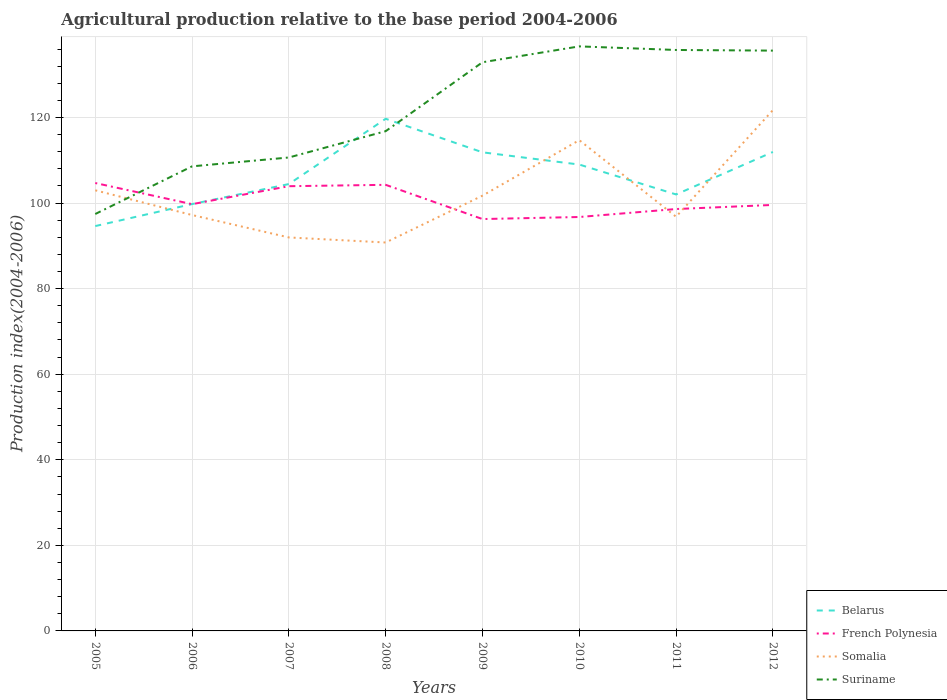Is the number of lines equal to the number of legend labels?
Make the answer very short. Yes. Across all years, what is the maximum agricultural production index in Somalia?
Your answer should be very brief. 90.79. In which year was the agricultural production index in Suriname maximum?
Keep it short and to the point. 2005. What is the total agricultural production index in Somalia in the graph?
Make the answer very short. 1.25. What is the difference between the highest and the second highest agricultural production index in Suriname?
Your answer should be very brief. 39.18. What is the difference between the highest and the lowest agricultural production index in Belarus?
Keep it short and to the point. 4. What is the difference between two consecutive major ticks on the Y-axis?
Give a very brief answer. 20. Does the graph contain grids?
Provide a short and direct response. Yes. Where does the legend appear in the graph?
Offer a very short reply. Bottom right. What is the title of the graph?
Offer a very short reply. Agricultural production relative to the base period 2004-2006. Does "Paraguay" appear as one of the legend labels in the graph?
Your answer should be compact. No. What is the label or title of the Y-axis?
Offer a very short reply. Production index(2004-2006). What is the Production index(2004-2006) in Belarus in 2005?
Your answer should be very brief. 94.63. What is the Production index(2004-2006) in French Polynesia in 2005?
Offer a very short reply. 104.69. What is the Production index(2004-2006) of Somalia in 2005?
Give a very brief answer. 102.99. What is the Production index(2004-2006) of Suriname in 2005?
Keep it short and to the point. 97.45. What is the Production index(2004-2006) of Belarus in 2006?
Offer a very short reply. 99.77. What is the Production index(2004-2006) of French Polynesia in 2006?
Offer a terse response. 99.75. What is the Production index(2004-2006) of Somalia in 2006?
Your answer should be very brief. 97.21. What is the Production index(2004-2006) in Suriname in 2006?
Provide a succinct answer. 108.59. What is the Production index(2004-2006) of Belarus in 2007?
Your answer should be compact. 104.45. What is the Production index(2004-2006) in French Polynesia in 2007?
Offer a very short reply. 103.95. What is the Production index(2004-2006) in Somalia in 2007?
Give a very brief answer. 91.97. What is the Production index(2004-2006) of Suriname in 2007?
Your answer should be compact. 110.66. What is the Production index(2004-2006) of Belarus in 2008?
Your answer should be compact. 119.71. What is the Production index(2004-2006) of French Polynesia in 2008?
Ensure brevity in your answer.  104.27. What is the Production index(2004-2006) of Somalia in 2008?
Provide a short and direct response. 90.79. What is the Production index(2004-2006) in Suriname in 2008?
Offer a terse response. 116.81. What is the Production index(2004-2006) of Belarus in 2009?
Make the answer very short. 111.87. What is the Production index(2004-2006) in French Polynesia in 2009?
Your response must be concise. 96.27. What is the Production index(2004-2006) in Somalia in 2009?
Your response must be concise. 101.74. What is the Production index(2004-2006) in Suriname in 2009?
Ensure brevity in your answer.  132.92. What is the Production index(2004-2006) in Belarus in 2010?
Your answer should be compact. 109.01. What is the Production index(2004-2006) in French Polynesia in 2010?
Your response must be concise. 96.75. What is the Production index(2004-2006) in Somalia in 2010?
Make the answer very short. 114.71. What is the Production index(2004-2006) of Suriname in 2010?
Give a very brief answer. 136.63. What is the Production index(2004-2006) in Belarus in 2011?
Provide a short and direct response. 102.02. What is the Production index(2004-2006) in French Polynesia in 2011?
Your response must be concise. 98.61. What is the Production index(2004-2006) of Somalia in 2011?
Give a very brief answer. 96.81. What is the Production index(2004-2006) of Suriname in 2011?
Offer a very short reply. 135.79. What is the Production index(2004-2006) in Belarus in 2012?
Provide a short and direct response. 111.95. What is the Production index(2004-2006) of French Polynesia in 2012?
Your answer should be compact. 99.57. What is the Production index(2004-2006) of Somalia in 2012?
Make the answer very short. 121.73. What is the Production index(2004-2006) in Suriname in 2012?
Give a very brief answer. 135.64. Across all years, what is the maximum Production index(2004-2006) in Belarus?
Give a very brief answer. 119.71. Across all years, what is the maximum Production index(2004-2006) in French Polynesia?
Give a very brief answer. 104.69. Across all years, what is the maximum Production index(2004-2006) in Somalia?
Ensure brevity in your answer.  121.73. Across all years, what is the maximum Production index(2004-2006) of Suriname?
Ensure brevity in your answer.  136.63. Across all years, what is the minimum Production index(2004-2006) of Belarus?
Offer a terse response. 94.63. Across all years, what is the minimum Production index(2004-2006) in French Polynesia?
Give a very brief answer. 96.27. Across all years, what is the minimum Production index(2004-2006) in Somalia?
Provide a succinct answer. 90.79. Across all years, what is the minimum Production index(2004-2006) of Suriname?
Offer a terse response. 97.45. What is the total Production index(2004-2006) in Belarus in the graph?
Offer a very short reply. 853.41. What is the total Production index(2004-2006) in French Polynesia in the graph?
Give a very brief answer. 803.86. What is the total Production index(2004-2006) in Somalia in the graph?
Give a very brief answer. 817.95. What is the total Production index(2004-2006) of Suriname in the graph?
Offer a very short reply. 974.49. What is the difference between the Production index(2004-2006) in Belarus in 2005 and that in 2006?
Ensure brevity in your answer.  -5.14. What is the difference between the Production index(2004-2006) of French Polynesia in 2005 and that in 2006?
Your answer should be very brief. 4.94. What is the difference between the Production index(2004-2006) of Somalia in 2005 and that in 2006?
Your answer should be very brief. 5.78. What is the difference between the Production index(2004-2006) in Suriname in 2005 and that in 2006?
Provide a short and direct response. -11.14. What is the difference between the Production index(2004-2006) in Belarus in 2005 and that in 2007?
Keep it short and to the point. -9.82. What is the difference between the Production index(2004-2006) in French Polynesia in 2005 and that in 2007?
Give a very brief answer. 0.74. What is the difference between the Production index(2004-2006) in Somalia in 2005 and that in 2007?
Your answer should be compact. 11.02. What is the difference between the Production index(2004-2006) in Suriname in 2005 and that in 2007?
Give a very brief answer. -13.21. What is the difference between the Production index(2004-2006) of Belarus in 2005 and that in 2008?
Provide a short and direct response. -25.08. What is the difference between the Production index(2004-2006) in French Polynesia in 2005 and that in 2008?
Make the answer very short. 0.42. What is the difference between the Production index(2004-2006) of Suriname in 2005 and that in 2008?
Your response must be concise. -19.36. What is the difference between the Production index(2004-2006) in Belarus in 2005 and that in 2009?
Provide a succinct answer. -17.24. What is the difference between the Production index(2004-2006) in French Polynesia in 2005 and that in 2009?
Offer a terse response. 8.42. What is the difference between the Production index(2004-2006) in Somalia in 2005 and that in 2009?
Offer a very short reply. 1.25. What is the difference between the Production index(2004-2006) of Suriname in 2005 and that in 2009?
Provide a succinct answer. -35.47. What is the difference between the Production index(2004-2006) of Belarus in 2005 and that in 2010?
Offer a terse response. -14.38. What is the difference between the Production index(2004-2006) in French Polynesia in 2005 and that in 2010?
Your response must be concise. 7.94. What is the difference between the Production index(2004-2006) in Somalia in 2005 and that in 2010?
Your answer should be compact. -11.72. What is the difference between the Production index(2004-2006) of Suriname in 2005 and that in 2010?
Give a very brief answer. -39.18. What is the difference between the Production index(2004-2006) of Belarus in 2005 and that in 2011?
Your answer should be very brief. -7.39. What is the difference between the Production index(2004-2006) in French Polynesia in 2005 and that in 2011?
Your answer should be very brief. 6.08. What is the difference between the Production index(2004-2006) in Somalia in 2005 and that in 2011?
Make the answer very short. 6.18. What is the difference between the Production index(2004-2006) in Suriname in 2005 and that in 2011?
Your answer should be compact. -38.34. What is the difference between the Production index(2004-2006) in Belarus in 2005 and that in 2012?
Provide a succinct answer. -17.32. What is the difference between the Production index(2004-2006) in French Polynesia in 2005 and that in 2012?
Provide a short and direct response. 5.12. What is the difference between the Production index(2004-2006) in Somalia in 2005 and that in 2012?
Provide a short and direct response. -18.74. What is the difference between the Production index(2004-2006) of Suriname in 2005 and that in 2012?
Provide a succinct answer. -38.19. What is the difference between the Production index(2004-2006) in Belarus in 2006 and that in 2007?
Make the answer very short. -4.68. What is the difference between the Production index(2004-2006) in Somalia in 2006 and that in 2007?
Offer a very short reply. 5.24. What is the difference between the Production index(2004-2006) in Suriname in 2006 and that in 2007?
Offer a very short reply. -2.07. What is the difference between the Production index(2004-2006) of Belarus in 2006 and that in 2008?
Ensure brevity in your answer.  -19.94. What is the difference between the Production index(2004-2006) of French Polynesia in 2006 and that in 2008?
Offer a terse response. -4.52. What is the difference between the Production index(2004-2006) in Somalia in 2006 and that in 2008?
Your answer should be very brief. 6.42. What is the difference between the Production index(2004-2006) in Suriname in 2006 and that in 2008?
Offer a very short reply. -8.22. What is the difference between the Production index(2004-2006) of French Polynesia in 2006 and that in 2009?
Your response must be concise. 3.48. What is the difference between the Production index(2004-2006) in Somalia in 2006 and that in 2009?
Give a very brief answer. -4.53. What is the difference between the Production index(2004-2006) of Suriname in 2006 and that in 2009?
Give a very brief answer. -24.33. What is the difference between the Production index(2004-2006) in Belarus in 2006 and that in 2010?
Offer a very short reply. -9.24. What is the difference between the Production index(2004-2006) of French Polynesia in 2006 and that in 2010?
Your response must be concise. 3. What is the difference between the Production index(2004-2006) of Somalia in 2006 and that in 2010?
Your answer should be compact. -17.5. What is the difference between the Production index(2004-2006) of Suriname in 2006 and that in 2010?
Offer a very short reply. -28.04. What is the difference between the Production index(2004-2006) of Belarus in 2006 and that in 2011?
Make the answer very short. -2.25. What is the difference between the Production index(2004-2006) in French Polynesia in 2006 and that in 2011?
Provide a succinct answer. 1.14. What is the difference between the Production index(2004-2006) in Somalia in 2006 and that in 2011?
Offer a very short reply. 0.4. What is the difference between the Production index(2004-2006) of Suriname in 2006 and that in 2011?
Your answer should be compact. -27.2. What is the difference between the Production index(2004-2006) in Belarus in 2006 and that in 2012?
Offer a very short reply. -12.18. What is the difference between the Production index(2004-2006) of French Polynesia in 2006 and that in 2012?
Your response must be concise. 0.18. What is the difference between the Production index(2004-2006) of Somalia in 2006 and that in 2012?
Offer a very short reply. -24.52. What is the difference between the Production index(2004-2006) in Suriname in 2006 and that in 2012?
Offer a terse response. -27.05. What is the difference between the Production index(2004-2006) in Belarus in 2007 and that in 2008?
Offer a terse response. -15.26. What is the difference between the Production index(2004-2006) of French Polynesia in 2007 and that in 2008?
Your answer should be very brief. -0.32. What is the difference between the Production index(2004-2006) of Somalia in 2007 and that in 2008?
Ensure brevity in your answer.  1.18. What is the difference between the Production index(2004-2006) of Suriname in 2007 and that in 2008?
Ensure brevity in your answer.  -6.15. What is the difference between the Production index(2004-2006) in Belarus in 2007 and that in 2009?
Offer a very short reply. -7.42. What is the difference between the Production index(2004-2006) of French Polynesia in 2007 and that in 2009?
Ensure brevity in your answer.  7.68. What is the difference between the Production index(2004-2006) of Somalia in 2007 and that in 2009?
Make the answer very short. -9.77. What is the difference between the Production index(2004-2006) of Suriname in 2007 and that in 2009?
Your answer should be compact. -22.26. What is the difference between the Production index(2004-2006) in Belarus in 2007 and that in 2010?
Your answer should be compact. -4.56. What is the difference between the Production index(2004-2006) in French Polynesia in 2007 and that in 2010?
Provide a short and direct response. 7.2. What is the difference between the Production index(2004-2006) in Somalia in 2007 and that in 2010?
Offer a terse response. -22.74. What is the difference between the Production index(2004-2006) of Suriname in 2007 and that in 2010?
Ensure brevity in your answer.  -25.97. What is the difference between the Production index(2004-2006) in Belarus in 2007 and that in 2011?
Provide a succinct answer. 2.43. What is the difference between the Production index(2004-2006) in French Polynesia in 2007 and that in 2011?
Provide a succinct answer. 5.34. What is the difference between the Production index(2004-2006) in Somalia in 2007 and that in 2011?
Offer a terse response. -4.84. What is the difference between the Production index(2004-2006) of Suriname in 2007 and that in 2011?
Make the answer very short. -25.13. What is the difference between the Production index(2004-2006) of Belarus in 2007 and that in 2012?
Keep it short and to the point. -7.5. What is the difference between the Production index(2004-2006) of French Polynesia in 2007 and that in 2012?
Ensure brevity in your answer.  4.38. What is the difference between the Production index(2004-2006) in Somalia in 2007 and that in 2012?
Ensure brevity in your answer.  -29.76. What is the difference between the Production index(2004-2006) of Suriname in 2007 and that in 2012?
Provide a short and direct response. -24.98. What is the difference between the Production index(2004-2006) of Belarus in 2008 and that in 2009?
Provide a succinct answer. 7.84. What is the difference between the Production index(2004-2006) in Somalia in 2008 and that in 2009?
Your answer should be compact. -10.95. What is the difference between the Production index(2004-2006) of Suriname in 2008 and that in 2009?
Make the answer very short. -16.11. What is the difference between the Production index(2004-2006) in French Polynesia in 2008 and that in 2010?
Keep it short and to the point. 7.52. What is the difference between the Production index(2004-2006) in Somalia in 2008 and that in 2010?
Your answer should be very brief. -23.92. What is the difference between the Production index(2004-2006) of Suriname in 2008 and that in 2010?
Make the answer very short. -19.82. What is the difference between the Production index(2004-2006) of Belarus in 2008 and that in 2011?
Ensure brevity in your answer.  17.69. What is the difference between the Production index(2004-2006) in French Polynesia in 2008 and that in 2011?
Offer a very short reply. 5.66. What is the difference between the Production index(2004-2006) of Somalia in 2008 and that in 2011?
Keep it short and to the point. -6.02. What is the difference between the Production index(2004-2006) of Suriname in 2008 and that in 2011?
Your answer should be compact. -18.98. What is the difference between the Production index(2004-2006) of Belarus in 2008 and that in 2012?
Make the answer very short. 7.76. What is the difference between the Production index(2004-2006) in Somalia in 2008 and that in 2012?
Give a very brief answer. -30.94. What is the difference between the Production index(2004-2006) in Suriname in 2008 and that in 2012?
Give a very brief answer. -18.83. What is the difference between the Production index(2004-2006) of Belarus in 2009 and that in 2010?
Provide a short and direct response. 2.86. What is the difference between the Production index(2004-2006) of French Polynesia in 2009 and that in 2010?
Keep it short and to the point. -0.48. What is the difference between the Production index(2004-2006) of Somalia in 2009 and that in 2010?
Offer a very short reply. -12.97. What is the difference between the Production index(2004-2006) of Suriname in 2009 and that in 2010?
Offer a terse response. -3.71. What is the difference between the Production index(2004-2006) of Belarus in 2009 and that in 2011?
Offer a very short reply. 9.85. What is the difference between the Production index(2004-2006) of French Polynesia in 2009 and that in 2011?
Provide a succinct answer. -2.34. What is the difference between the Production index(2004-2006) in Somalia in 2009 and that in 2011?
Your response must be concise. 4.93. What is the difference between the Production index(2004-2006) in Suriname in 2009 and that in 2011?
Provide a short and direct response. -2.87. What is the difference between the Production index(2004-2006) in Belarus in 2009 and that in 2012?
Provide a short and direct response. -0.08. What is the difference between the Production index(2004-2006) in French Polynesia in 2009 and that in 2012?
Keep it short and to the point. -3.3. What is the difference between the Production index(2004-2006) in Somalia in 2009 and that in 2012?
Give a very brief answer. -19.99. What is the difference between the Production index(2004-2006) in Suriname in 2009 and that in 2012?
Keep it short and to the point. -2.72. What is the difference between the Production index(2004-2006) in Belarus in 2010 and that in 2011?
Provide a short and direct response. 6.99. What is the difference between the Production index(2004-2006) of French Polynesia in 2010 and that in 2011?
Your answer should be compact. -1.86. What is the difference between the Production index(2004-2006) of Somalia in 2010 and that in 2011?
Provide a short and direct response. 17.9. What is the difference between the Production index(2004-2006) in Suriname in 2010 and that in 2011?
Provide a short and direct response. 0.84. What is the difference between the Production index(2004-2006) of Belarus in 2010 and that in 2012?
Keep it short and to the point. -2.94. What is the difference between the Production index(2004-2006) in French Polynesia in 2010 and that in 2012?
Give a very brief answer. -2.82. What is the difference between the Production index(2004-2006) of Somalia in 2010 and that in 2012?
Your response must be concise. -7.02. What is the difference between the Production index(2004-2006) in Suriname in 2010 and that in 2012?
Provide a short and direct response. 0.99. What is the difference between the Production index(2004-2006) of Belarus in 2011 and that in 2012?
Ensure brevity in your answer.  -9.93. What is the difference between the Production index(2004-2006) in French Polynesia in 2011 and that in 2012?
Give a very brief answer. -0.96. What is the difference between the Production index(2004-2006) of Somalia in 2011 and that in 2012?
Your response must be concise. -24.92. What is the difference between the Production index(2004-2006) in Belarus in 2005 and the Production index(2004-2006) in French Polynesia in 2006?
Provide a short and direct response. -5.12. What is the difference between the Production index(2004-2006) of Belarus in 2005 and the Production index(2004-2006) of Somalia in 2006?
Your response must be concise. -2.58. What is the difference between the Production index(2004-2006) in Belarus in 2005 and the Production index(2004-2006) in Suriname in 2006?
Your response must be concise. -13.96. What is the difference between the Production index(2004-2006) of French Polynesia in 2005 and the Production index(2004-2006) of Somalia in 2006?
Offer a very short reply. 7.48. What is the difference between the Production index(2004-2006) of Somalia in 2005 and the Production index(2004-2006) of Suriname in 2006?
Ensure brevity in your answer.  -5.6. What is the difference between the Production index(2004-2006) of Belarus in 2005 and the Production index(2004-2006) of French Polynesia in 2007?
Make the answer very short. -9.32. What is the difference between the Production index(2004-2006) in Belarus in 2005 and the Production index(2004-2006) in Somalia in 2007?
Your answer should be compact. 2.66. What is the difference between the Production index(2004-2006) in Belarus in 2005 and the Production index(2004-2006) in Suriname in 2007?
Give a very brief answer. -16.03. What is the difference between the Production index(2004-2006) in French Polynesia in 2005 and the Production index(2004-2006) in Somalia in 2007?
Give a very brief answer. 12.72. What is the difference between the Production index(2004-2006) in French Polynesia in 2005 and the Production index(2004-2006) in Suriname in 2007?
Your answer should be compact. -5.97. What is the difference between the Production index(2004-2006) in Somalia in 2005 and the Production index(2004-2006) in Suriname in 2007?
Keep it short and to the point. -7.67. What is the difference between the Production index(2004-2006) in Belarus in 2005 and the Production index(2004-2006) in French Polynesia in 2008?
Offer a terse response. -9.64. What is the difference between the Production index(2004-2006) in Belarus in 2005 and the Production index(2004-2006) in Somalia in 2008?
Your response must be concise. 3.84. What is the difference between the Production index(2004-2006) of Belarus in 2005 and the Production index(2004-2006) of Suriname in 2008?
Your response must be concise. -22.18. What is the difference between the Production index(2004-2006) of French Polynesia in 2005 and the Production index(2004-2006) of Suriname in 2008?
Give a very brief answer. -12.12. What is the difference between the Production index(2004-2006) in Somalia in 2005 and the Production index(2004-2006) in Suriname in 2008?
Provide a succinct answer. -13.82. What is the difference between the Production index(2004-2006) in Belarus in 2005 and the Production index(2004-2006) in French Polynesia in 2009?
Ensure brevity in your answer.  -1.64. What is the difference between the Production index(2004-2006) of Belarus in 2005 and the Production index(2004-2006) of Somalia in 2009?
Provide a succinct answer. -7.11. What is the difference between the Production index(2004-2006) in Belarus in 2005 and the Production index(2004-2006) in Suriname in 2009?
Keep it short and to the point. -38.29. What is the difference between the Production index(2004-2006) in French Polynesia in 2005 and the Production index(2004-2006) in Somalia in 2009?
Ensure brevity in your answer.  2.95. What is the difference between the Production index(2004-2006) in French Polynesia in 2005 and the Production index(2004-2006) in Suriname in 2009?
Give a very brief answer. -28.23. What is the difference between the Production index(2004-2006) in Somalia in 2005 and the Production index(2004-2006) in Suriname in 2009?
Keep it short and to the point. -29.93. What is the difference between the Production index(2004-2006) of Belarus in 2005 and the Production index(2004-2006) of French Polynesia in 2010?
Ensure brevity in your answer.  -2.12. What is the difference between the Production index(2004-2006) in Belarus in 2005 and the Production index(2004-2006) in Somalia in 2010?
Offer a terse response. -20.08. What is the difference between the Production index(2004-2006) of Belarus in 2005 and the Production index(2004-2006) of Suriname in 2010?
Ensure brevity in your answer.  -42. What is the difference between the Production index(2004-2006) in French Polynesia in 2005 and the Production index(2004-2006) in Somalia in 2010?
Your answer should be very brief. -10.02. What is the difference between the Production index(2004-2006) of French Polynesia in 2005 and the Production index(2004-2006) of Suriname in 2010?
Keep it short and to the point. -31.94. What is the difference between the Production index(2004-2006) of Somalia in 2005 and the Production index(2004-2006) of Suriname in 2010?
Give a very brief answer. -33.64. What is the difference between the Production index(2004-2006) of Belarus in 2005 and the Production index(2004-2006) of French Polynesia in 2011?
Offer a very short reply. -3.98. What is the difference between the Production index(2004-2006) of Belarus in 2005 and the Production index(2004-2006) of Somalia in 2011?
Your response must be concise. -2.18. What is the difference between the Production index(2004-2006) in Belarus in 2005 and the Production index(2004-2006) in Suriname in 2011?
Offer a terse response. -41.16. What is the difference between the Production index(2004-2006) in French Polynesia in 2005 and the Production index(2004-2006) in Somalia in 2011?
Your answer should be very brief. 7.88. What is the difference between the Production index(2004-2006) of French Polynesia in 2005 and the Production index(2004-2006) of Suriname in 2011?
Make the answer very short. -31.1. What is the difference between the Production index(2004-2006) of Somalia in 2005 and the Production index(2004-2006) of Suriname in 2011?
Your answer should be very brief. -32.8. What is the difference between the Production index(2004-2006) of Belarus in 2005 and the Production index(2004-2006) of French Polynesia in 2012?
Provide a succinct answer. -4.94. What is the difference between the Production index(2004-2006) of Belarus in 2005 and the Production index(2004-2006) of Somalia in 2012?
Keep it short and to the point. -27.1. What is the difference between the Production index(2004-2006) in Belarus in 2005 and the Production index(2004-2006) in Suriname in 2012?
Make the answer very short. -41.01. What is the difference between the Production index(2004-2006) in French Polynesia in 2005 and the Production index(2004-2006) in Somalia in 2012?
Provide a short and direct response. -17.04. What is the difference between the Production index(2004-2006) of French Polynesia in 2005 and the Production index(2004-2006) of Suriname in 2012?
Your answer should be very brief. -30.95. What is the difference between the Production index(2004-2006) in Somalia in 2005 and the Production index(2004-2006) in Suriname in 2012?
Offer a terse response. -32.65. What is the difference between the Production index(2004-2006) of Belarus in 2006 and the Production index(2004-2006) of French Polynesia in 2007?
Provide a short and direct response. -4.18. What is the difference between the Production index(2004-2006) of Belarus in 2006 and the Production index(2004-2006) of Suriname in 2007?
Provide a short and direct response. -10.89. What is the difference between the Production index(2004-2006) in French Polynesia in 2006 and the Production index(2004-2006) in Somalia in 2007?
Your answer should be compact. 7.78. What is the difference between the Production index(2004-2006) in French Polynesia in 2006 and the Production index(2004-2006) in Suriname in 2007?
Ensure brevity in your answer.  -10.91. What is the difference between the Production index(2004-2006) in Somalia in 2006 and the Production index(2004-2006) in Suriname in 2007?
Give a very brief answer. -13.45. What is the difference between the Production index(2004-2006) in Belarus in 2006 and the Production index(2004-2006) in Somalia in 2008?
Provide a succinct answer. 8.98. What is the difference between the Production index(2004-2006) of Belarus in 2006 and the Production index(2004-2006) of Suriname in 2008?
Ensure brevity in your answer.  -17.04. What is the difference between the Production index(2004-2006) in French Polynesia in 2006 and the Production index(2004-2006) in Somalia in 2008?
Make the answer very short. 8.96. What is the difference between the Production index(2004-2006) of French Polynesia in 2006 and the Production index(2004-2006) of Suriname in 2008?
Keep it short and to the point. -17.06. What is the difference between the Production index(2004-2006) in Somalia in 2006 and the Production index(2004-2006) in Suriname in 2008?
Make the answer very short. -19.6. What is the difference between the Production index(2004-2006) of Belarus in 2006 and the Production index(2004-2006) of Somalia in 2009?
Your answer should be compact. -1.97. What is the difference between the Production index(2004-2006) of Belarus in 2006 and the Production index(2004-2006) of Suriname in 2009?
Give a very brief answer. -33.15. What is the difference between the Production index(2004-2006) in French Polynesia in 2006 and the Production index(2004-2006) in Somalia in 2009?
Your answer should be very brief. -1.99. What is the difference between the Production index(2004-2006) of French Polynesia in 2006 and the Production index(2004-2006) of Suriname in 2009?
Provide a succinct answer. -33.17. What is the difference between the Production index(2004-2006) of Somalia in 2006 and the Production index(2004-2006) of Suriname in 2009?
Give a very brief answer. -35.71. What is the difference between the Production index(2004-2006) in Belarus in 2006 and the Production index(2004-2006) in French Polynesia in 2010?
Make the answer very short. 3.02. What is the difference between the Production index(2004-2006) in Belarus in 2006 and the Production index(2004-2006) in Somalia in 2010?
Your answer should be very brief. -14.94. What is the difference between the Production index(2004-2006) in Belarus in 2006 and the Production index(2004-2006) in Suriname in 2010?
Provide a short and direct response. -36.86. What is the difference between the Production index(2004-2006) of French Polynesia in 2006 and the Production index(2004-2006) of Somalia in 2010?
Make the answer very short. -14.96. What is the difference between the Production index(2004-2006) of French Polynesia in 2006 and the Production index(2004-2006) of Suriname in 2010?
Your response must be concise. -36.88. What is the difference between the Production index(2004-2006) in Somalia in 2006 and the Production index(2004-2006) in Suriname in 2010?
Your response must be concise. -39.42. What is the difference between the Production index(2004-2006) of Belarus in 2006 and the Production index(2004-2006) of French Polynesia in 2011?
Offer a very short reply. 1.16. What is the difference between the Production index(2004-2006) in Belarus in 2006 and the Production index(2004-2006) in Somalia in 2011?
Provide a succinct answer. 2.96. What is the difference between the Production index(2004-2006) of Belarus in 2006 and the Production index(2004-2006) of Suriname in 2011?
Your answer should be very brief. -36.02. What is the difference between the Production index(2004-2006) of French Polynesia in 2006 and the Production index(2004-2006) of Somalia in 2011?
Offer a very short reply. 2.94. What is the difference between the Production index(2004-2006) in French Polynesia in 2006 and the Production index(2004-2006) in Suriname in 2011?
Your response must be concise. -36.04. What is the difference between the Production index(2004-2006) in Somalia in 2006 and the Production index(2004-2006) in Suriname in 2011?
Your answer should be compact. -38.58. What is the difference between the Production index(2004-2006) of Belarus in 2006 and the Production index(2004-2006) of French Polynesia in 2012?
Your response must be concise. 0.2. What is the difference between the Production index(2004-2006) in Belarus in 2006 and the Production index(2004-2006) in Somalia in 2012?
Your response must be concise. -21.96. What is the difference between the Production index(2004-2006) of Belarus in 2006 and the Production index(2004-2006) of Suriname in 2012?
Your answer should be very brief. -35.87. What is the difference between the Production index(2004-2006) of French Polynesia in 2006 and the Production index(2004-2006) of Somalia in 2012?
Provide a succinct answer. -21.98. What is the difference between the Production index(2004-2006) in French Polynesia in 2006 and the Production index(2004-2006) in Suriname in 2012?
Provide a short and direct response. -35.89. What is the difference between the Production index(2004-2006) in Somalia in 2006 and the Production index(2004-2006) in Suriname in 2012?
Make the answer very short. -38.43. What is the difference between the Production index(2004-2006) in Belarus in 2007 and the Production index(2004-2006) in French Polynesia in 2008?
Keep it short and to the point. 0.18. What is the difference between the Production index(2004-2006) in Belarus in 2007 and the Production index(2004-2006) in Somalia in 2008?
Your response must be concise. 13.66. What is the difference between the Production index(2004-2006) in Belarus in 2007 and the Production index(2004-2006) in Suriname in 2008?
Your answer should be compact. -12.36. What is the difference between the Production index(2004-2006) of French Polynesia in 2007 and the Production index(2004-2006) of Somalia in 2008?
Your answer should be very brief. 13.16. What is the difference between the Production index(2004-2006) of French Polynesia in 2007 and the Production index(2004-2006) of Suriname in 2008?
Provide a succinct answer. -12.86. What is the difference between the Production index(2004-2006) in Somalia in 2007 and the Production index(2004-2006) in Suriname in 2008?
Provide a succinct answer. -24.84. What is the difference between the Production index(2004-2006) in Belarus in 2007 and the Production index(2004-2006) in French Polynesia in 2009?
Keep it short and to the point. 8.18. What is the difference between the Production index(2004-2006) of Belarus in 2007 and the Production index(2004-2006) of Somalia in 2009?
Make the answer very short. 2.71. What is the difference between the Production index(2004-2006) of Belarus in 2007 and the Production index(2004-2006) of Suriname in 2009?
Offer a very short reply. -28.47. What is the difference between the Production index(2004-2006) in French Polynesia in 2007 and the Production index(2004-2006) in Somalia in 2009?
Your answer should be very brief. 2.21. What is the difference between the Production index(2004-2006) of French Polynesia in 2007 and the Production index(2004-2006) of Suriname in 2009?
Your answer should be compact. -28.97. What is the difference between the Production index(2004-2006) in Somalia in 2007 and the Production index(2004-2006) in Suriname in 2009?
Give a very brief answer. -40.95. What is the difference between the Production index(2004-2006) of Belarus in 2007 and the Production index(2004-2006) of French Polynesia in 2010?
Keep it short and to the point. 7.7. What is the difference between the Production index(2004-2006) of Belarus in 2007 and the Production index(2004-2006) of Somalia in 2010?
Provide a short and direct response. -10.26. What is the difference between the Production index(2004-2006) of Belarus in 2007 and the Production index(2004-2006) of Suriname in 2010?
Give a very brief answer. -32.18. What is the difference between the Production index(2004-2006) of French Polynesia in 2007 and the Production index(2004-2006) of Somalia in 2010?
Give a very brief answer. -10.76. What is the difference between the Production index(2004-2006) of French Polynesia in 2007 and the Production index(2004-2006) of Suriname in 2010?
Offer a very short reply. -32.68. What is the difference between the Production index(2004-2006) in Somalia in 2007 and the Production index(2004-2006) in Suriname in 2010?
Your response must be concise. -44.66. What is the difference between the Production index(2004-2006) of Belarus in 2007 and the Production index(2004-2006) of French Polynesia in 2011?
Provide a succinct answer. 5.84. What is the difference between the Production index(2004-2006) in Belarus in 2007 and the Production index(2004-2006) in Somalia in 2011?
Your answer should be compact. 7.64. What is the difference between the Production index(2004-2006) of Belarus in 2007 and the Production index(2004-2006) of Suriname in 2011?
Provide a succinct answer. -31.34. What is the difference between the Production index(2004-2006) in French Polynesia in 2007 and the Production index(2004-2006) in Somalia in 2011?
Give a very brief answer. 7.14. What is the difference between the Production index(2004-2006) of French Polynesia in 2007 and the Production index(2004-2006) of Suriname in 2011?
Provide a short and direct response. -31.84. What is the difference between the Production index(2004-2006) in Somalia in 2007 and the Production index(2004-2006) in Suriname in 2011?
Your answer should be compact. -43.82. What is the difference between the Production index(2004-2006) of Belarus in 2007 and the Production index(2004-2006) of French Polynesia in 2012?
Keep it short and to the point. 4.88. What is the difference between the Production index(2004-2006) of Belarus in 2007 and the Production index(2004-2006) of Somalia in 2012?
Give a very brief answer. -17.28. What is the difference between the Production index(2004-2006) of Belarus in 2007 and the Production index(2004-2006) of Suriname in 2012?
Ensure brevity in your answer.  -31.19. What is the difference between the Production index(2004-2006) of French Polynesia in 2007 and the Production index(2004-2006) of Somalia in 2012?
Give a very brief answer. -17.78. What is the difference between the Production index(2004-2006) in French Polynesia in 2007 and the Production index(2004-2006) in Suriname in 2012?
Provide a short and direct response. -31.69. What is the difference between the Production index(2004-2006) of Somalia in 2007 and the Production index(2004-2006) of Suriname in 2012?
Offer a terse response. -43.67. What is the difference between the Production index(2004-2006) in Belarus in 2008 and the Production index(2004-2006) in French Polynesia in 2009?
Offer a very short reply. 23.44. What is the difference between the Production index(2004-2006) in Belarus in 2008 and the Production index(2004-2006) in Somalia in 2009?
Provide a succinct answer. 17.97. What is the difference between the Production index(2004-2006) in Belarus in 2008 and the Production index(2004-2006) in Suriname in 2009?
Your answer should be very brief. -13.21. What is the difference between the Production index(2004-2006) of French Polynesia in 2008 and the Production index(2004-2006) of Somalia in 2009?
Your answer should be compact. 2.53. What is the difference between the Production index(2004-2006) in French Polynesia in 2008 and the Production index(2004-2006) in Suriname in 2009?
Offer a terse response. -28.65. What is the difference between the Production index(2004-2006) in Somalia in 2008 and the Production index(2004-2006) in Suriname in 2009?
Offer a terse response. -42.13. What is the difference between the Production index(2004-2006) of Belarus in 2008 and the Production index(2004-2006) of French Polynesia in 2010?
Your answer should be compact. 22.96. What is the difference between the Production index(2004-2006) in Belarus in 2008 and the Production index(2004-2006) in Somalia in 2010?
Provide a succinct answer. 5. What is the difference between the Production index(2004-2006) in Belarus in 2008 and the Production index(2004-2006) in Suriname in 2010?
Ensure brevity in your answer.  -16.92. What is the difference between the Production index(2004-2006) in French Polynesia in 2008 and the Production index(2004-2006) in Somalia in 2010?
Provide a short and direct response. -10.44. What is the difference between the Production index(2004-2006) of French Polynesia in 2008 and the Production index(2004-2006) of Suriname in 2010?
Give a very brief answer. -32.36. What is the difference between the Production index(2004-2006) of Somalia in 2008 and the Production index(2004-2006) of Suriname in 2010?
Keep it short and to the point. -45.84. What is the difference between the Production index(2004-2006) in Belarus in 2008 and the Production index(2004-2006) in French Polynesia in 2011?
Give a very brief answer. 21.1. What is the difference between the Production index(2004-2006) of Belarus in 2008 and the Production index(2004-2006) of Somalia in 2011?
Your answer should be very brief. 22.9. What is the difference between the Production index(2004-2006) in Belarus in 2008 and the Production index(2004-2006) in Suriname in 2011?
Provide a succinct answer. -16.08. What is the difference between the Production index(2004-2006) in French Polynesia in 2008 and the Production index(2004-2006) in Somalia in 2011?
Ensure brevity in your answer.  7.46. What is the difference between the Production index(2004-2006) of French Polynesia in 2008 and the Production index(2004-2006) of Suriname in 2011?
Make the answer very short. -31.52. What is the difference between the Production index(2004-2006) of Somalia in 2008 and the Production index(2004-2006) of Suriname in 2011?
Your answer should be compact. -45. What is the difference between the Production index(2004-2006) of Belarus in 2008 and the Production index(2004-2006) of French Polynesia in 2012?
Your response must be concise. 20.14. What is the difference between the Production index(2004-2006) of Belarus in 2008 and the Production index(2004-2006) of Somalia in 2012?
Your answer should be compact. -2.02. What is the difference between the Production index(2004-2006) of Belarus in 2008 and the Production index(2004-2006) of Suriname in 2012?
Your response must be concise. -15.93. What is the difference between the Production index(2004-2006) of French Polynesia in 2008 and the Production index(2004-2006) of Somalia in 2012?
Make the answer very short. -17.46. What is the difference between the Production index(2004-2006) in French Polynesia in 2008 and the Production index(2004-2006) in Suriname in 2012?
Your answer should be very brief. -31.37. What is the difference between the Production index(2004-2006) of Somalia in 2008 and the Production index(2004-2006) of Suriname in 2012?
Give a very brief answer. -44.85. What is the difference between the Production index(2004-2006) of Belarus in 2009 and the Production index(2004-2006) of French Polynesia in 2010?
Give a very brief answer. 15.12. What is the difference between the Production index(2004-2006) in Belarus in 2009 and the Production index(2004-2006) in Somalia in 2010?
Your answer should be compact. -2.84. What is the difference between the Production index(2004-2006) of Belarus in 2009 and the Production index(2004-2006) of Suriname in 2010?
Ensure brevity in your answer.  -24.76. What is the difference between the Production index(2004-2006) of French Polynesia in 2009 and the Production index(2004-2006) of Somalia in 2010?
Keep it short and to the point. -18.44. What is the difference between the Production index(2004-2006) in French Polynesia in 2009 and the Production index(2004-2006) in Suriname in 2010?
Give a very brief answer. -40.36. What is the difference between the Production index(2004-2006) of Somalia in 2009 and the Production index(2004-2006) of Suriname in 2010?
Offer a terse response. -34.89. What is the difference between the Production index(2004-2006) in Belarus in 2009 and the Production index(2004-2006) in French Polynesia in 2011?
Provide a short and direct response. 13.26. What is the difference between the Production index(2004-2006) of Belarus in 2009 and the Production index(2004-2006) of Somalia in 2011?
Make the answer very short. 15.06. What is the difference between the Production index(2004-2006) in Belarus in 2009 and the Production index(2004-2006) in Suriname in 2011?
Ensure brevity in your answer.  -23.92. What is the difference between the Production index(2004-2006) in French Polynesia in 2009 and the Production index(2004-2006) in Somalia in 2011?
Your answer should be very brief. -0.54. What is the difference between the Production index(2004-2006) of French Polynesia in 2009 and the Production index(2004-2006) of Suriname in 2011?
Offer a terse response. -39.52. What is the difference between the Production index(2004-2006) of Somalia in 2009 and the Production index(2004-2006) of Suriname in 2011?
Keep it short and to the point. -34.05. What is the difference between the Production index(2004-2006) of Belarus in 2009 and the Production index(2004-2006) of Somalia in 2012?
Provide a succinct answer. -9.86. What is the difference between the Production index(2004-2006) of Belarus in 2009 and the Production index(2004-2006) of Suriname in 2012?
Provide a succinct answer. -23.77. What is the difference between the Production index(2004-2006) of French Polynesia in 2009 and the Production index(2004-2006) of Somalia in 2012?
Provide a succinct answer. -25.46. What is the difference between the Production index(2004-2006) of French Polynesia in 2009 and the Production index(2004-2006) of Suriname in 2012?
Your answer should be compact. -39.37. What is the difference between the Production index(2004-2006) of Somalia in 2009 and the Production index(2004-2006) of Suriname in 2012?
Give a very brief answer. -33.9. What is the difference between the Production index(2004-2006) in Belarus in 2010 and the Production index(2004-2006) in French Polynesia in 2011?
Provide a succinct answer. 10.4. What is the difference between the Production index(2004-2006) of Belarus in 2010 and the Production index(2004-2006) of Suriname in 2011?
Ensure brevity in your answer.  -26.78. What is the difference between the Production index(2004-2006) in French Polynesia in 2010 and the Production index(2004-2006) in Somalia in 2011?
Offer a very short reply. -0.06. What is the difference between the Production index(2004-2006) of French Polynesia in 2010 and the Production index(2004-2006) of Suriname in 2011?
Your response must be concise. -39.04. What is the difference between the Production index(2004-2006) of Somalia in 2010 and the Production index(2004-2006) of Suriname in 2011?
Offer a terse response. -21.08. What is the difference between the Production index(2004-2006) of Belarus in 2010 and the Production index(2004-2006) of French Polynesia in 2012?
Provide a short and direct response. 9.44. What is the difference between the Production index(2004-2006) in Belarus in 2010 and the Production index(2004-2006) in Somalia in 2012?
Your answer should be compact. -12.72. What is the difference between the Production index(2004-2006) in Belarus in 2010 and the Production index(2004-2006) in Suriname in 2012?
Give a very brief answer. -26.63. What is the difference between the Production index(2004-2006) in French Polynesia in 2010 and the Production index(2004-2006) in Somalia in 2012?
Your response must be concise. -24.98. What is the difference between the Production index(2004-2006) in French Polynesia in 2010 and the Production index(2004-2006) in Suriname in 2012?
Provide a succinct answer. -38.89. What is the difference between the Production index(2004-2006) of Somalia in 2010 and the Production index(2004-2006) of Suriname in 2012?
Offer a very short reply. -20.93. What is the difference between the Production index(2004-2006) in Belarus in 2011 and the Production index(2004-2006) in French Polynesia in 2012?
Make the answer very short. 2.45. What is the difference between the Production index(2004-2006) of Belarus in 2011 and the Production index(2004-2006) of Somalia in 2012?
Offer a very short reply. -19.71. What is the difference between the Production index(2004-2006) in Belarus in 2011 and the Production index(2004-2006) in Suriname in 2012?
Make the answer very short. -33.62. What is the difference between the Production index(2004-2006) of French Polynesia in 2011 and the Production index(2004-2006) of Somalia in 2012?
Your answer should be very brief. -23.12. What is the difference between the Production index(2004-2006) in French Polynesia in 2011 and the Production index(2004-2006) in Suriname in 2012?
Offer a very short reply. -37.03. What is the difference between the Production index(2004-2006) in Somalia in 2011 and the Production index(2004-2006) in Suriname in 2012?
Your response must be concise. -38.83. What is the average Production index(2004-2006) of Belarus per year?
Ensure brevity in your answer.  106.68. What is the average Production index(2004-2006) of French Polynesia per year?
Give a very brief answer. 100.48. What is the average Production index(2004-2006) in Somalia per year?
Provide a succinct answer. 102.24. What is the average Production index(2004-2006) of Suriname per year?
Provide a succinct answer. 121.81. In the year 2005, what is the difference between the Production index(2004-2006) of Belarus and Production index(2004-2006) of French Polynesia?
Give a very brief answer. -10.06. In the year 2005, what is the difference between the Production index(2004-2006) in Belarus and Production index(2004-2006) in Somalia?
Provide a short and direct response. -8.36. In the year 2005, what is the difference between the Production index(2004-2006) in Belarus and Production index(2004-2006) in Suriname?
Keep it short and to the point. -2.82. In the year 2005, what is the difference between the Production index(2004-2006) of French Polynesia and Production index(2004-2006) of Suriname?
Provide a short and direct response. 7.24. In the year 2005, what is the difference between the Production index(2004-2006) in Somalia and Production index(2004-2006) in Suriname?
Provide a short and direct response. 5.54. In the year 2006, what is the difference between the Production index(2004-2006) of Belarus and Production index(2004-2006) of French Polynesia?
Your answer should be compact. 0.02. In the year 2006, what is the difference between the Production index(2004-2006) of Belarus and Production index(2004-2006) of Somalia?
Your answer should be very brief. 2.56. In the year 2006, what is the difference between the Production index(2004-2006) of Belarus and Production index(2004-2006) of Suriname?
Offer a very short reply. -8.82. In the year 2006, what is the difference between the Production index(2004-2006) of French Polynesia and Production index(2004-2006) of Somalia?
Ensure brevity in your answer.  2.54. In the year 2006, what is the difference between the Production index(2004-2006) of French Polynesia and Production index(2004-2006) of Suriname?
Your answer should be very brief. -8.84. In the year 2006, what is the difference between the Production index(2004-2006) in Somalia and Production index(2004-2006) in Suriname?
Ensure brevity in your answer.  -11.38. In the year 2007, what is the difference between the Production index(2004-2006) in Belarus and Production index(2004-2006) in Somalia?
Provide a short and direct response. 12.48. In the year 2007, what is the difference between the Production index(2004-2006) of Belarus and Production index(2004-2006) of Suriname?
Your answer should be very brief. -6.21. In the year 2007, what is the difference between the Production index(2004-2006) of French Polynesia and Production index(2004-2006) of Somalia?
Ensure brevity in your answer.  11.98. In the year 2007, what is the difference between the Production index(2004-2006) of French Polynesia and Production index(2004-2006) of Suriname?
Offer a very short reply. -6.71. In the year 2007, what is the difference between the Production index(2004-2006) in Somalia and Production index(2004-2006) in Suriname?
Offer a terse response. -18.69. In the year 2008, what is the difference between the Production index(2004-2006) in Belarus and Production index(2004-2006) in French Polynesia?
Your response must be concise. 15.44. In the year 2008, what is the difference between the Production index(2004-2006) in Belarus and Production index(2004-2006) in Somalia?
Your response must be concise. 28.92. In the year 2008, what is the difference between the Production index(2004-2006) of Belarus and Production index(2004-2006) of Suriname?
Provide a succinct answer. 2.9. In the year 2008, what is the difference between the Production index(2004-2006) of French Polynesia and Production index(2004-2006) of Somalia?
Provide a succinct answer. 13.48. In the year 2008, what is the difference between the Production index(2004-2006) in French Polynesia and Production index(2004-2006) in Suriname?
Keep it short and to the point. -12.54. In the year 2008, what is the difference between the Production index(2004-2006) in Somalia and Production index(2004-2006) in Suriname?
Your answer should be compact. -26.02. In the year 2009, what is the difference between the Production index(2004-2006) in Belarus and Production index(2004-2006) in French Polynesia?
Your response must be concise. 15.6. In the year 2009, what is the difference between the Production index(2004-2006) in Belarus and Production index(2004-2006) in Somalia?
Provide a succinct answer. 10.13. In the year 2009, what is the difference between the Production index(2004-2006) in Belarus and Production index(2004-2006) in Suriname?
Your answer should be very brief. -21.05. In the year 2009, what is the difference between the Production index(2004-2006) of French Polynesia and Production index(2004-2006) of Somalia?
Keep it short and to the point. -5.47. In the year 2009, what is the difference between the Production index(2004-2006) of French Polynesia and Production index(2004-2006) of Suriname?
Provide a succinct answer. -36.65. In the year 2009, what is the difference between the Production index(2004-2006) of Somalia and Production index(2004-2006) of Suriname?
Offer a very short reply. -31.18. In the year 2010, what is the difference between the Production index(2004-2006) of Belarus and Production index(2004-2006) of French Polynesia?
Your answer should be compact. 12.26. In the year 2010, what is the difference between the Production index(2004-2006) in Belarus and Production index(2004-2006) in Suriname?
Give a very brief answer. -27.62. In the year 2010, what is the difference between the Production index(2004-2006) in French Polynesia and Production index(2004-2006) in Somalia?
Your answer should be very brief. -17.96. In the year 2010, what is the difference between the Production index(2004-2006) of French Polynesia and Production index(2004-2006) of Suriname?
Your answer should be compact. -39.88. In the year 2010, what is the difference between the Production index(2004-2006) of Somalia and Production index(2004-2006) of Suriname?
Provide a succinct answer. -21.92. In the year 2011, what is the difference between the Production index(2004-2006) of Belarus and Production index(2004-2006) of French Polynesia?
Keep it short and to the point. 3.41. In the year 2011, what is the difference between the Production index(2004-2006) in Belarus and Production index(2004-2006) in Somalia?
Make the answer very short. 5.21. In the year 2011, what is the difference between the Production index(2004-2006) of Belarus and Production index(2004-2006) of Suriname?
Your answer should be very brief. -33.77. In the year 2011, what is the difference between the Production index(2004-2006) of French Polynesia and Production index(2004-2006) of Suriname?
Keep it short and to the point. -37.18. In the year 2011, what is the difference between the Production index(2004-2006) of Somalia and Production index(2004-2006) of Suriname?
Give a very brief answer. -38.98. In the year 2012, what is the difference between the Production index(2004-2006) of Belarus and Production index(2004-2006) of French Polynesia?
Provide a succinct answer. 12.38. In the year 2012, what is the difference between the Production index(2004-2006) in Belarus and Production index(2004-2006) in Somalia?
Ensure brevity in your answer.  -9.78. In the year 2012, what is the difference between the Production index(2004-2006) in Belarus and Production index(2004-2006) in Suriname?
Provide a short and direct response. -23.69. In the year 2012, what is the difference between the Production index(2004-2006) in French Polynesia and Production index(2004-2006) in Somalia?
Your answer should be compact. -22.16. In the year 2012, what is the difference between the Production index(2004-2006) in French Polynesia and Production index(2004-2006) in Suriname?
Make the answer very short. -36.07. In the year 2012, what is the difference between the Production index(2004-2006) of Somalia and Production index(2004-2006) of Suriname?
Offer a terse response. -13.91. What is the ratio of the Production index(2004-2006) in Belarus in 2005 to that in 2006?
Offer a terse response. 0.95. What is the ratio of the Production index(2004-2006) of French Polynesia in 2005 to that in 2006?
Your answer should be very brief. 1.05. What is the ratio of the Production index(2004-2006) in Somalia in 2005 to that in 2006?
Offer a very short reply. 1.06. What is the ratio of the Production index(2004-2006) in Suriname in 2005 to that in 2006?
Your answer should be compact. 0.9. What is the ratio of the Production index(2004-2006) of Belarus in 2005 to that in 2007?
Provide a short and direct response. 0.91. What is the ratio of the Production index(2004-2006) in French Polynesia in 2005 to that in 2007?
Ensure brevity in your answer.  1.01. What is the ratio of the Production index(2004-2006) of Somalia in 2005 to that in 2007?
Offer a terse response. 1.12. What is the ratio of the Production index(2004-2006) of Suriname in 2005 to that in 2007?
Ensure brevity in your answer.  0.88. What is the ratio of the Production index(2004-2006) of Belarus in 2005 to that in 2008?
Make the answer very short. 0.79. What is the ratio of the Production index(2004-2006) of French Polynesia in 2005 to that in 2008?
Keep it short and to the point. 1. What is the ratio of the Production index(2004-2006) of Somalia in 2005 to that in 2008?
Offer a very short reply. 1.13. What is the ratio of the Production index(2004-2006) in Suriname in 2005 to that in 2008?
Provide a short and direct response. 0.83. What is the ratio of the Production index(2004-2006) in Belarus in 2005 to that in 2009?
Give a very brief answer. 0.85. What is the ratio of the Production index(2004-2006) of French Polynesia in 2005 to that in 2009?
Make the answer very short. 1.09. What is the ratio of the Production index(2004-2006) of Somalia in 2005 to that in 2009?
Offer a terse response. 1.01. What is the ratio of the Production index(2004-2006) of Suriname in 2005 to that in 2009?
Provide a short and direct response. 0.73. What is the ratio of the Production index(2004-2006) of Belarus in 2005 to that in 2010?
Make the answer very short. 0.87. What is the ratio of the Production index(2004-2006) of French Polynesia in 2005 to that in 2010?
Your response must be concise. 1.08. What is the ratio of the Production index(2004-2006) in Somalia in 2005 to that in 2010?
Give a very brief answer. 0.9. What is the ratio of the Production index(2004-2006) in Suriname in 2005 to that in 2010?
Give a very brief answer. 0.71. What is the ratio of the Production index(2004-2006) of Belarus in 2005 to that in 2011?
Your answer should be compact. 0.93. What is the ratio of the Production index(2004-2006) in French Polynesia in 2005 to that in 2011?
Your answer should be compact. 1.06. What is the ratio of the Production index(2004-2006) of Somalia in 2005 to that in 2011?
Your answer should be compact. 1.06. What is the ratio of the Production index(2004-2006) of Suriname in 2005 to that in 2011?
Your answer should be very brief. 0.72. What is the ratio of the Production index(2004-2006) of Belarus in 2005 to that in 2012?
Your answer should be very brief. 0.85. What is the ratio of the Production index(2004-2006) of French Polynesia in 2005 to that in 2012?
Make the answer very short. 1.05. What is the ratio of the Production index(2004-2006) in Somalia in 2005 to that in 2012?
Your answer should be compact. 0.85. What is the ratio of the Production index(2004-2006) in Suriname in 2005 to that in 2012?
Make the answer very short. 0.72. What is the ratio of the Production index(2004-2006) in Belarus in 2006 to that in 2007?
Give a very brief answer. 0.96. What is the ratio of the Production index(2004-2006) in French Polynesia in 2006 to that in 2007?
Make the answer very short. 0.96. What is the ratio of the Production index(2004-2006) in Somalia in 2006 to that in 2007?
Offer a terse response. 1.06. What is the ratio of the Production index(2004-2006) in Suriname in 2006 to that in 2007?
Provide a succinct answer. 0.98. What is the ratio of the Production index(2004-2006) of Belarus in 2006 to that in 2008?
Provide a succinct answer. 0.83. What is the ratio of the Production index(2004-2006) in French Polynesia in 2006 to that in 2008?
Provide a succinct answer. 0.96. What is the ratio of the Production index(2004-2006) of Somalia in 2006 to that in 2008?
Make the answer very short. 1.07. What is the ratio of the Production index(2004-2006) in Suriname in 2006 to that in 2008?
Offer a terse response. 0.93. What is the ratio of the Production index(2004-2006) of Belarus in 2006 to that in 2009?
Give a very brief answer. 0.89. What is the ratio of the Production index(2004-2006) of French Polynesia in 2006 to that in 2009?
Make the answer very short. 1.04. What is the ratio of the Production index(2004-2006) in Somalia in 2006 to that in 2009?
Give a very brief answer. 0.96. What is the ratio of the Production index(2004-2006) of Suriname in 2006 to that in 2009?
Your answer should be very brief. 0.82. What is the ratio of the Production index(2004-2006) of Belarus in 2006 to that in 2010?
Give a very brief answer. 0.92. What is the ratio of the Production index(2004-2006) of French Polynesia in 2006 to that in 2010?
Offer a very short reply. 1.03. What is the ratio of the Production index(2004-2006) of Somalia in 2006 to that in 2010?
Provide a succinct answer. 0.85. What is the ratio of the Production index(2004-2006) of Suriname in 2006 to that in 2010?
Give a very brief answer. 0.79. What is the ratio of the Production index(2004-2006) in Belarus in 2006 to that in 2011?
Ensure brevity in your answer.  0.98. What is the ratio of the Production index(2004-2006) in French Polynesia in 2006 to that in 2011?
Your answer should be compact. 1.01. What is the ratio of the Production index(2004-2006) of Suriname in 2006 to that in 2011?
Give a very brief answer. 0.8. What is the ratio of the Production index(2004-2006) in Belarus in 2006 to that in 2012?
Your answer should be very brief. 0.89. What is the ratio of the Production index(2004-2006) in French Polynesia in 2006 to that in 2012?
Your answer should be compact. 1. What is the ratio of the Production index(2004-2006) of Somalia in 2006 to that in 2012?
Your response must be concise. 0.8. What is the ratio of the Production index(2004-2006) in Suriname in 2006 to that in 2012?
Provide a succinct answer. 0.8. What is the ratio of the Production index(2004-2006) of Belarus in 2007 to that in 2008?
Offer a very short reply. 0.87. What is the ratio of the Production index(2004-2006) of French Polynesia in 2007 to that in 2008?
Your answer should be very brief. 1. What is the ratio of the Production index(2004-2006) in Suriname in 2007 to that in 2008?
Give a very brief answer. 0.95. What is the ratio of the Production index(2004-2006) of Belarus in 2007 to that in 2009?
Offer a terse response. 0.93. What is the ratio of the Production index(2004-2006) in French Polynesia in 2007 to that in 2009?
Ensure brevity in your answer.  1.08. What is the ratio of the Production index(2004-2006) in Somalia in 2007 to that in 2009?
Keep it short and to the point. 0.9. What is the ratio of the Production index(2004-2006) in Suriname in 2007 to that in 2009?
Make the answer very short. 0.83. What is the ratio of the Production index(2004-2006) of Belarus in 2007 to that in 2010?
Your answer should be very brief. 0.96. What is the ratio of the Production index(2004-2006) in French Polynesia in 2007 to that in 2010?
Your answer should be very brief. 1.07. What is the ratio of the Production index(2004-2006) in Somalia in 2007 to that in 2010?
Offer a very short reply. 0.8. What is the ratio of the Production index(2004-2006) of Suriname in 2007 to that in 2010?
Give a very brief answer. 0.81. What is the ratio of the Production index(2004-2006) of Belarus in 2007 to that in 2011?
Your answer should be compact. 1.02. What is the ratio of the Production index(2004-2006) in French Polynesia in 2007 to that in 2011?
Offer a very short reply. 1.05. What is the ratio of the Production index(2004-2006) of Suriname in 2007 to that in 2011?
Your response must be concise. 0.81. What is the ratio of the Production index(2004-2006) of Belarus in 2007 to that in 2012?
Provide a succinct answer. 0.93. What is the ratio of the Production index(2004-2006) in French Polynesia in 2007 to that in 2012?
Make the answer very short. 1.04. What is the ratio of the Production index(2004-2006) in Somalia in 2007 to that in 2012?
Your response must be concise. 0.76. What is the ratio of the Production index(2004-2006) of Suriname in 2007 to that in 2012?
Your answer should be very brief. 0.82. What is the ratio of the Production index(2004-2006) in Belarus in 2008 to that in 2009?
Provide a succinct answer. 1.07. What is the ratio of the Production index(2004-2006) of French Polynesia in 2008 to that in 2009?
Offer a very short reply. 1.08. What is the ratio of the Production index(2004-2006) of Somalia in 2008 to that in 2009?
Ensure brevity in your answer.  0.89. What is the ratio of the Production index(2004-2006) in Suriname in 2008 to that in 2009?
Your answer should be compact. 0.88. What is the ratio of the Production index(2004-2006) in Belarus in 2008 to that in 2010?
Your answer should be very brief. 1.1. What is the ratio of the Production index(2004-2006) of French Polynesia in 2008 to that in 2010?
Provide a succinct answer. 1.08. What is the ratio of the Production index(2004-2006) of Somalia in 2008 to that in 2010?
Your answer should be compact. 0.79. What is the ratio of the Production index(2004-2006) of Suriname in 2008 to that in 2010?
Make the answer very short. 0.85. What is the ratio of the Production index(2004-2006) of Belarus in 2008 to that in 2011?
Keep it short and to the point. 1.17. What is the ratio of the Production index(2004-2006) in French Polynesia in 2008 to that in 2011?
Keep it short and to the point. 1.06. What is the ratio of the Production index(2004-2006) of Somalia in 2008 to that in 2011?
Keep it short and to the point. 0.94. What is the ratio of the Production index(2004-2006) in Suriname in 2008 to that in 2011?
Your answer should be compact. 0.86. What is the ratio of the Production index(2004-2006) in Belarus in 2008 to that in 2012?
Give a very brief answer. 1.07. What is the ratio of the Production index(2004-2006) of French Polynesia in 2008 to that in 2012?
Offer a very short reply. 1.05. What is the ratio of the Production index(2004-2006) of Somalia in 2008 to that in 2012?
Provide a succinct answer. 0.75. What is the ratio of the Production index(2004-2006) in Suriname in 2008 to that in 2012?
Provide a succinct answer. 0.86. What is the ratio of the Production index(2004-2006) in Belarus in 2009 to that in 2010?
Offer a very short reply. 1.03. What is the ratio of the Production index(2004-2006) in French Polynesia in 2009 to that in 2010?
Keep it short and to the point. 0.99. What is the ratio of the Production index(2004-2006) in Somalia in 2009 to that in 2010?
Provide a succinct answer. 0.89. What is the ratio of the Production index(2004-2006) in Suriname in 2009 to that in 2010?
Give a very brief answer. 0.97. What is the ratio of the Production index(2004-2006) in Belarus in 2009 to that in 2011?
Keep it short and to the point. 1.1. What is the ratio of the Production index(2004-2006) of French Polynesia in 2009 to that in 2011?
Your answer should be very brief. 0.98. What is the ratio of the Production index(2004-2006) in Somalia in 2009 to that in 2011?
Offer a very short reply. 1.05. What is the ratio of the Production index(2004-2006) of Suriname in 2009 to that in 2011?
Provide a succinct answer. 0.98. What is the ratio of the Production index(2004-2006) in Belarus in 2009 to that in 2012?
Offer a very short reply. 1. What is the ratio of the Production index(2004-2006) of French Polynesia in 2009 to that in 2012?
Keep it short and to the point. 0.97. What is the ratio of the Production index(2004-2006) of Somalia in 2009 to that in 2012?
Your answer should be compact. 0.84. What is the ratio of the Production index(2004-2006) of Suriname in 2009 to that in 2012?
Ensure brevity in your answer.  0.98. What is the ratio of the Production index(2004-2006) of Belarus in 2010 to that in 2011?
Offer a terse response. 1.07. What is the ratio of the Production index(2004-2006) of French Polynesia in 2010 to that in 2011?
Give a very brief answer. 0.98. What is the ratio of the Production index(2004-2006) of Somalia in 2010 to that in 2011?
Keep it short and to the point. 1.18. What is the ratio of the Production index(2004-2006) in Suriname in 2010 to that in 2011?
Your answer should be compact. 1.01. What is the ratio of the Production index(2004-2006) of Belarus in 2010 to that in 2012?
Provide a succinct answer. 0.97. What is the ratio of the Production index(2004-2006) in French Polynesia in 2010 to that in 2012?
Ensure brevity in your answer.  0.97. What is the ratio of the Production index(2004-2006) in Somalia in 2010 to that in 2012?
Your answer should be compact. 0.94. What is the ratio of the Production index(2004-2006) of Suriname in 2010 to that in 2012?
Your answer should be very brief. 1.01. What is the ratio of the Production index(2004-2006) in Belarus in 2011 to that in 2012?
Keep it short and to the point. 0.91. What is the ratio of the Production index(2004-2006) in French Polynesia in 2011 to that in 2012?
Your answer should be very brief. 0.99. What is the ratio of the Production index(2004-2006) in Somalia in 2011 to that in 2012?
Provide a succinct answer. 0.8. What is the ratio of the Production index(2004-2006) in Suriname in 2011 to that in 2012?
Offer a terse response. 1. What is the difference between the highest and the second highest Production index(2004-2006) of Belarus?
Provide a short and direct response. 7.76. What is the difference between the highest and the second highest Production index(2004-2006) in French Polynesia?
Give a very brief answer. 0.42. What is the difference between the highest and the second highest Production index(2004-2006) of Somalia?
Offer a terse response. 7.02. What is the difference between the highest and the second highest Production index(2004-2006) in Suriname?
Keep it short and to the point. 0.84. What is the difference between the highest and the lowest Production index(2004-2006) in Belarus?
Your answer should be compact. 25.08. What is the difference between the highest and the lowest Production index(2004-2006) in French Polynesia?
Your response must be concise. 8.42. What is the difference between the highest and the lowest Production index(2004-2006) of Somalia?
Provide a succinct answer. 30.94. What is the difference between the highest and the lowest Production index(2004-2006) in Suriname?
Offer a terse response. 39.18. 